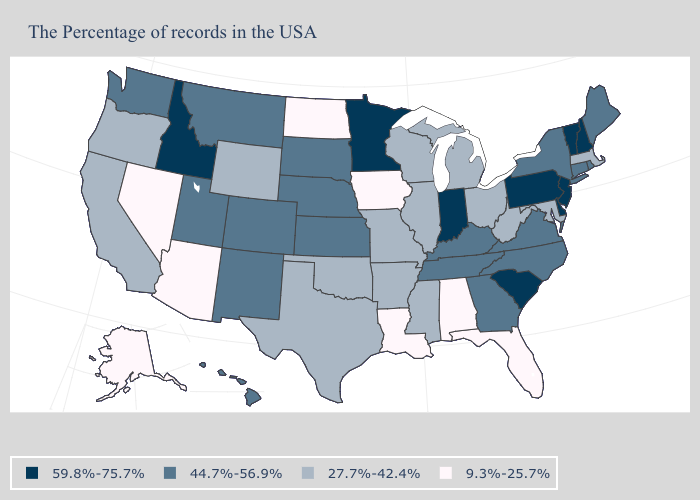Name the states that have a value in the range 9.3%-25.7%?
Quick response, please. Florida, Alabama, Louisiana, Iowa, North Dakota, Arizona, Nevada, Alaska. Name the states that have a value in the range 27.7%-42.4%?
Keep it brief. Massachusetts, Maryland, West Virginia, Ohio, Michigan, Wisconsin, Illinois, Mississippi, Missouri, Arkansas, Oklahoma, Texas, Wyoming, California, Oregon. What is the highest value in the USA?
Answer briefly. 59.8%-75.7%. What is the highest value in the USA?
Keep it brief. 59.8%-75.7%. What is the value of Wyoming?
Be succinct. 27.7%-42.4%. Does Wyoming have the same value as Maryland?
Answer briefly. Yes. What is the lowest value in the West?
Give a very brief answer. 9.3%-25.7%. What is the lowest value in the USA?
Be succinct. 9.3%-25.7%. Name the states that have a value in the range 9.3%-25.7%?
Quick response, please. Florida, Alabama, Louisiana, Iowa, North Dakota, Arizona, Nevada, Alaska. How many symbols are there in the legend?
Give a very brief answer. 4. Does Massachusetts have the lowest value in the Northeast?
Short answer required. Yes. Name the states that have a value in the range 9.3%-25.7%?
Quick response, please. Florida, Alabama, Louisiana, Iowa, North Dakota, Arizona, Nevada, Alaska. Does West Virginia have the same value as Iowa?
Short answer required. No. Name the states that have a value in the range 9.3%-25.7%?
Short answer required. Florida, Alabama, Louisiana, Iowa, North Dakota, Arizona, Nevada, Alaska. 